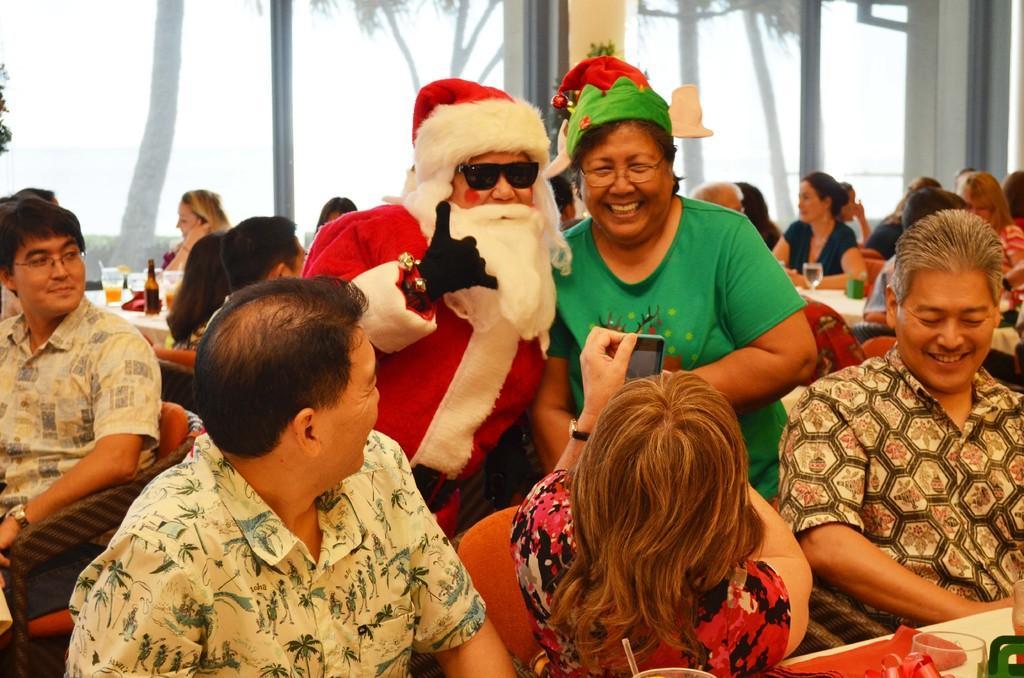Can you describe this image briefly? In this image, we can see people sitting and tables. On top of the table, there are few objects. Few people are smiling. In the middle of the image, we can see two person standing. At the bottom of the image, we can see a woman holding a mobile. In the background, we can see glass windows. Through the glasses, we can see trees. 